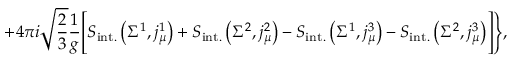<formula> <loc_0><loc_0><loc_500><loc_500>+ 4 \pi i \sqrt { \frac { 2 } { 3 } } \frac { 1 } { g } \Big [ S _ { i n t . } \left ( \Sigma ^ { 1 } , j _ { \mu } ^ { 1 } \right ) + S _ { i n t . } \left ( \Sigma ^ { 2 } , j _ { \mu } ^ { 2 } \right ) - S _ { i n t . } \left ( \Sigma ^ { 1 } , j _ { \mu } ^ { 3 } \right ) - S _ { i n t . } \left ( \Sigma ^ { 2 } , j _ { \mu } ^ { 3 } \right ) \Big ] \Big \} ,</formula> 